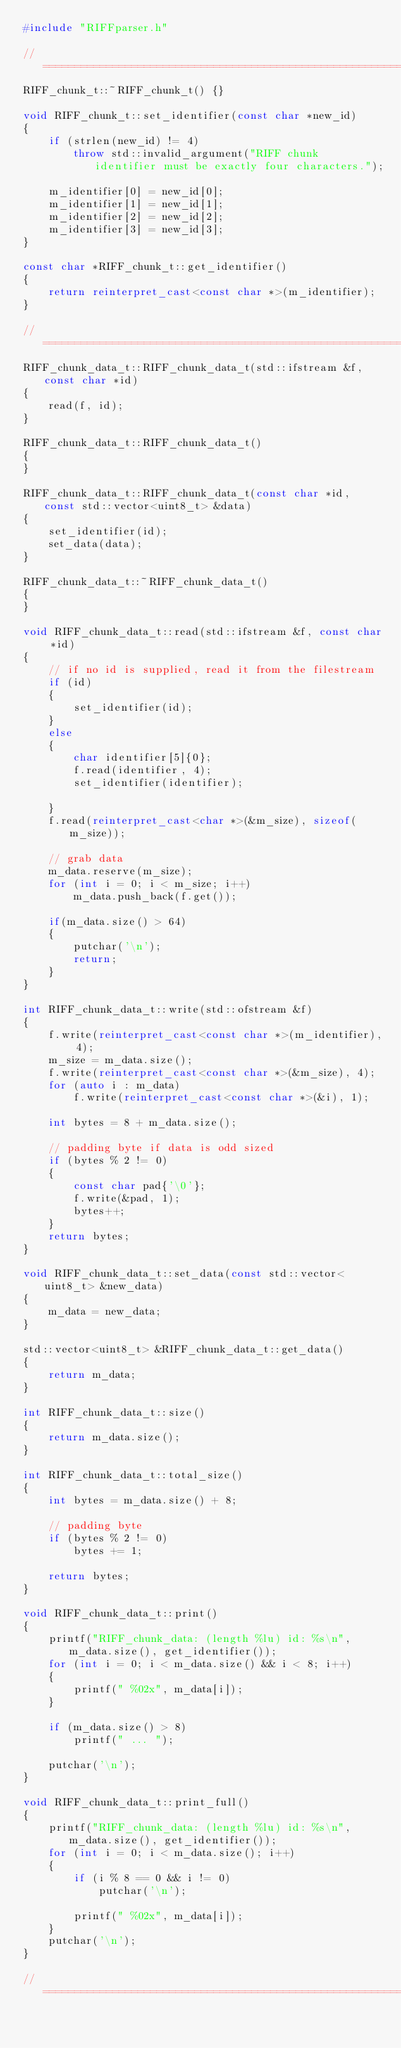<code> <loc_0><loc_0><loc_500><loc_500><_C++_>#include "RIFFparser.h"

// ====================================================================================================================
RIFF_chunk_t::~RIFF_chunk_t() {}

void RIFF_chunk_t::set_identifier(const char *new_id)
{
    if (strlen(new_id) != 4)
        throw std::invalid_argument("RIFF chunk identifier must be exactly four characters.");

    m_identifier[0] = new_id[0];
    m_identifier[1] = new_id[1];
    m_identifier[2] = new_id[2];
    m_identifier[3] = new_id[3];
}

const char *RIFF_chunk_t::get_identifier()
{
    return reinterpret_cast<const char *>(m_identifier);
}

// ====================================================================================================================
RIFF_chunk_data_t::RIFF_chunk_data_t(std::ifstream &f, const char *id)
{
    read(f, id);
}

RIFF_chunk_data_t::RIFF_chunk_data_t()
{
}

RIFF_chunk_data_t::RIFF_chunk_data_t(const char *id, const std::vector<uint8_t> &data)
{
    set_identifier(id);
    set_data(data);
}

RIFF_chunk_data_t::~RIFF_chunk_data_t()
{
}

void RIFF_chunk_data_t::read(std::ifstream &f, const char *id)
{
    // if no id is supplied, read it from the filestream
    if (id)
    {
        set_identifier(id);
    }
    else
    {
        char identifier[5]{0};
        f.read(identifier, 4);
        set_identifier(identifier);

    }
    f.read(reinterpret_cast<char *>(&m_size), sizeof(m_size));

    // grab data
    m_data.reserve(m_size);
    for (int i = 0; i < m_size; i++)
        m_data.push_back(f.get());

    if(m_data.size() > 64)
    {
        putchar('\n');
        return;
    }
}

int RIFF_chunk_data_t::write(std::ofstream &f)
{
    f.write(reinterpret_cast<const char *>(m_identifier), 4);
    m_size = m_data.size();
    f.write(reinterpret_cast<const char *>(&m_size), 4);
    for (auto i : m_data)
        f.write(reinterpret_cast<const char *>(&i), 1);

    int bytes = 8 + m_data.size();

    // padding byte if data is odd sized
    if (bytes % 2 != 0)
    {
        const char pad{'\0'};
        f.write(&pad, 1);
        bytes++;
    }
    return bytes;
}

void RIFF_chunk_data_t::set_data(const std::vector<uint8_t> &new_data)
{
    m_data = new_data;
}

std::vector<uint8_t> &RIFF_chunk_data_t::get_data()
{
    return m_data;
}

int RIFF_chunk_data_t::size()
{
    return m_data.size();
}

int RIFF_chunk_data_t::total_size()
{
    int bytes = m_data.size() + 8;

    // padding byte
    if (bytes % 2 != 0)
        bytes += 1;

    return bytes;
}

void RIFF_chunk_data_t::print()
{
    printf("RIFF_chunk_data: (length %lu) id: %s\n", m_data.size(), get_identifier());
    for (int i = 0; i < m_data.size() && i < 8; i++)
    {
        printf(" %02x", m_data[i]);
    }

    if (m_data.size() > 8)
        printf(" ... ");

    putchar('\n');
}

void RIFF_chunk_data_t::print_full()
{
    printf("RIFF_chunk_data: (length %lu) id: %s\n", m_data.size(), get_identifier());
    for (int i = 0; i < m_data.size(); i++)
    {
        if (i % 8 == 0 && i != 0)
            putchar('\n');

        printf(" %02x", m_data[i]);
    }
    putchar('\n');
}

// ====================================================================================================================</code> 